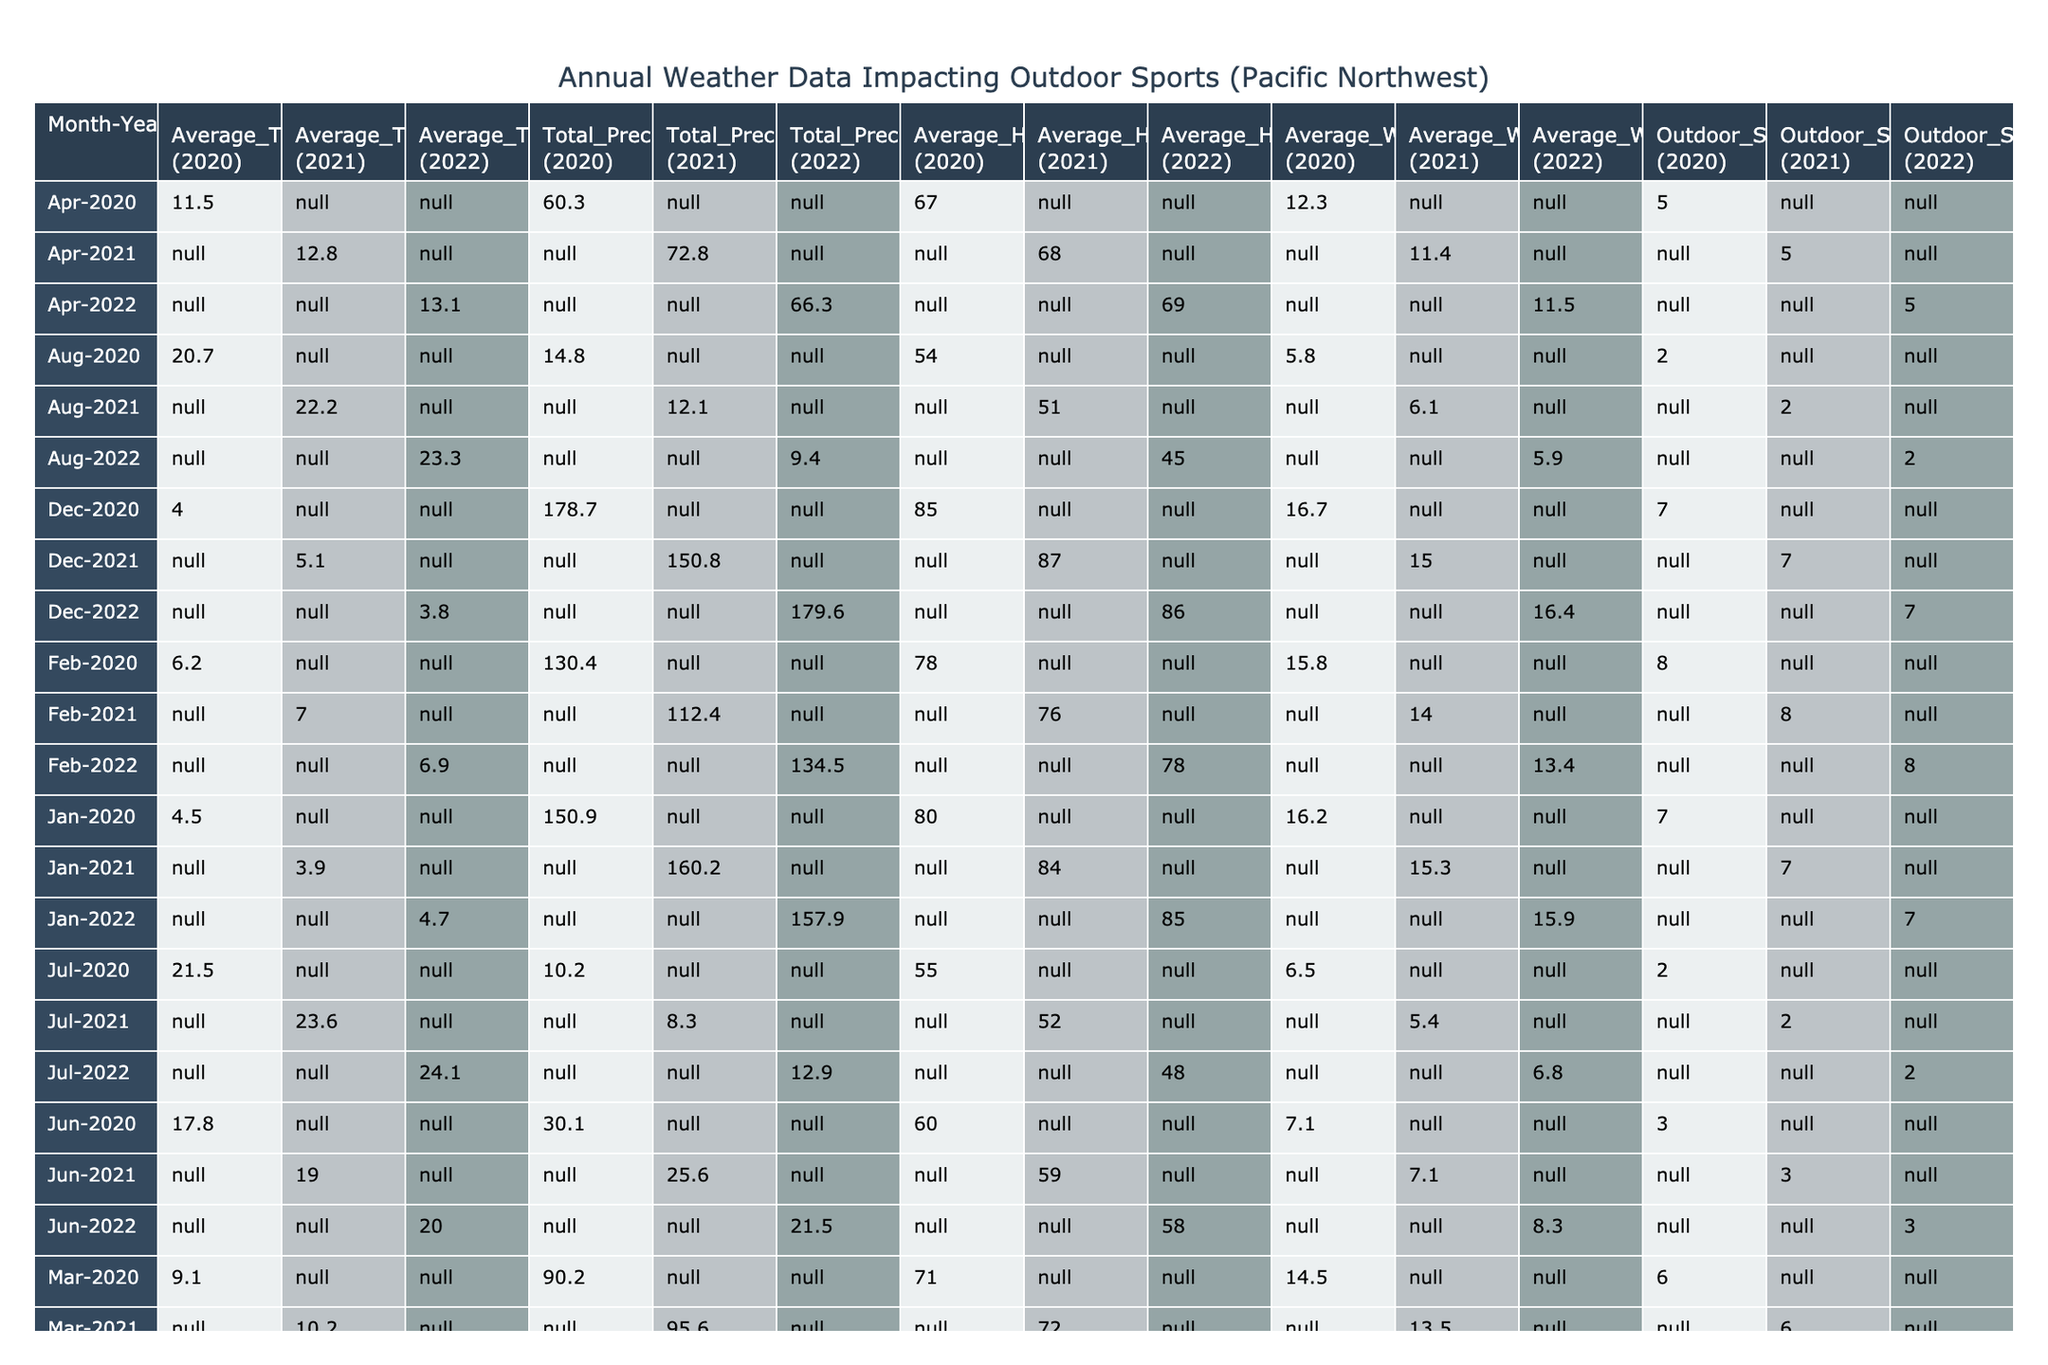What was the average temperature in July 2021? The table indicates the average temperature in July 2021 is 23.6°C.
Answer: 23.6°C What is the total precipitation recorded in November 2022? According to the table, the total precipitation for November 2022 is 167.3 mm.
Answer: 167.3 mm Is the average wind speed higher in January or December 2020? The average wind speed in January 2020 is 16.2 km/h and in December 2020 is 16.7 km/h. Therefore, December has a higher wind speed.
Answer: Yes What is the average impact score for outdoor sports in May across the three years? The impact scores for May are 4 (2020), 4 (2021), and 4 (2022). Their average is (4 + 4 + 4) / 3 = 4.
Answer: 4 Which month in 2021 had the highest outdoor sport impact score? The highest outdoor sport impact score in 2021 is 8 for February and November. Consideration is taken for both months as they share the peak score.
Answer: February and November What is the change in total precipitation from March 2020 to March 2022? The total precipitation in March 2020 is 90.2 mm and in March 2022 is 101.2 mm. The change is 101.2 mm - 90.2 mm = 11 mm increase.
Answer: 11 mm increase Did the average humidity increase or decrease from June 2020 to June 2022? The average humidity in June 2020 is 60% and June 2022 is 58%. This indicates a decrease in humidity.
Answer: Decrease Calculate the average total precipitation over the entire data set provided. Total precipitation is calculated by summing each month's total precipitation across the three years: (150.9 + 130.4 + 90.2 + 60.3 + 45.0 + 30.1 + 10.2 + 14.8 + 50.2 + 140.5 + 155.2 + 178.7 + 160.2 + 112.4 + 95.6 + 72.8 + 50.7 + 25.6 + 8.3 + 12.1 + 43.5 + 130.1 + 162.4 + 150.8 + 157.9 + 134.5 + 101.2 + 66.3 + 52.1 + 21.5 + 12.9 + 9.4 + 39.7 + 129.5 + 167.3 + 179.6) = 2,308.2 mm, and since there are 36 months, the average is 2,308.2 / 36 = 64.7 mm.
Answer: 64.7 mm Which year experienced the lowest average temperature across all months? A comparison shows that the average temperatures for each year are approximately: 2020 at 12.0°C, 2021 at 12.3°C, and 2022 at 12.2°C. Therefore, 2020 had the lowest average temperature.
Answer: 2020 If the average wind speed in April 2020 and April 2021 were to be combined, what would be the average wind speed for those months? The average wind speed is 12.3 km/h (2020) and 11.4 km/h (2021). The combined average is (12.3 + 11.4) / 2 = 11.85 km/h, rounding gives 11.9 km/h.
Answer: 11.9 km/h 